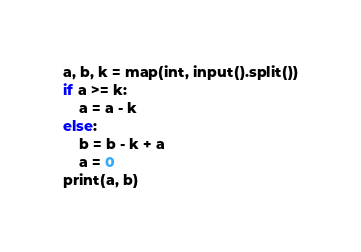<code> <loc_0><loc_0><loc_500><loc_500><_Python_>a, b, k = map(int, input().split())
if a >= k:
	a = a - k
else:
	b = b - k + a
	a = 0
print(a, b)
</code> 